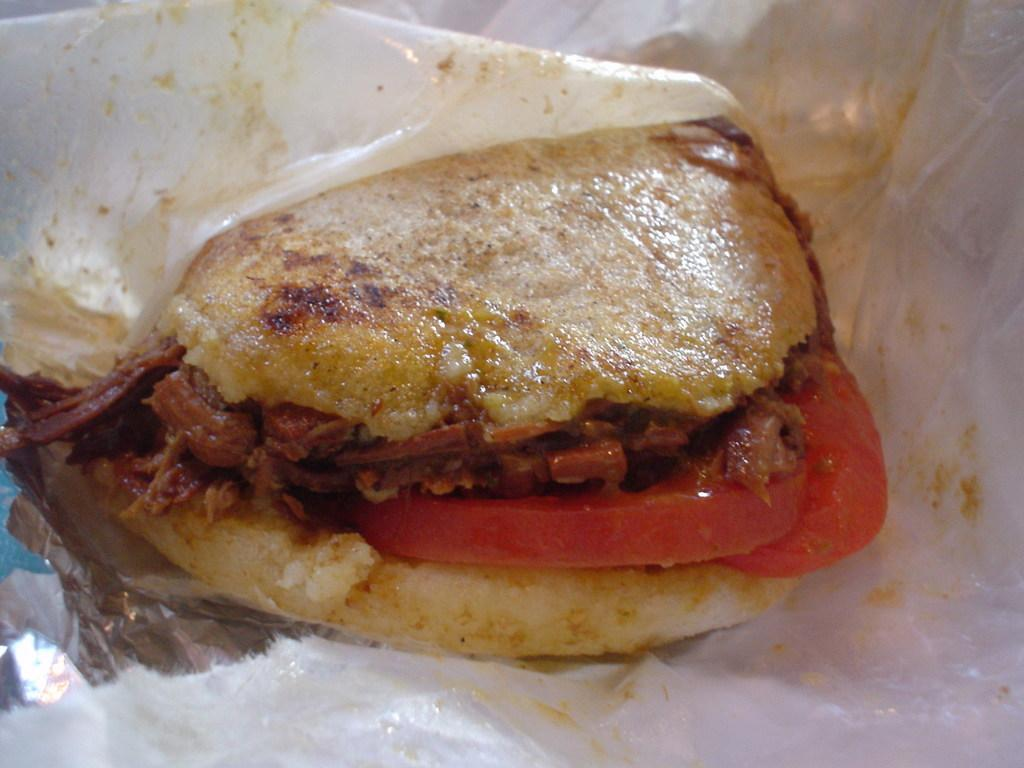What type of food can be seen in the image? The image contains food, but the specific type is not mentioned in the facts. What is the material of the foil paper in the image? The foil paper in the image is made of aluminum. What relation does the flag have to the food in the image? There is no flag present in the image, so it is not possible to determine any relation between a flag and the food. 